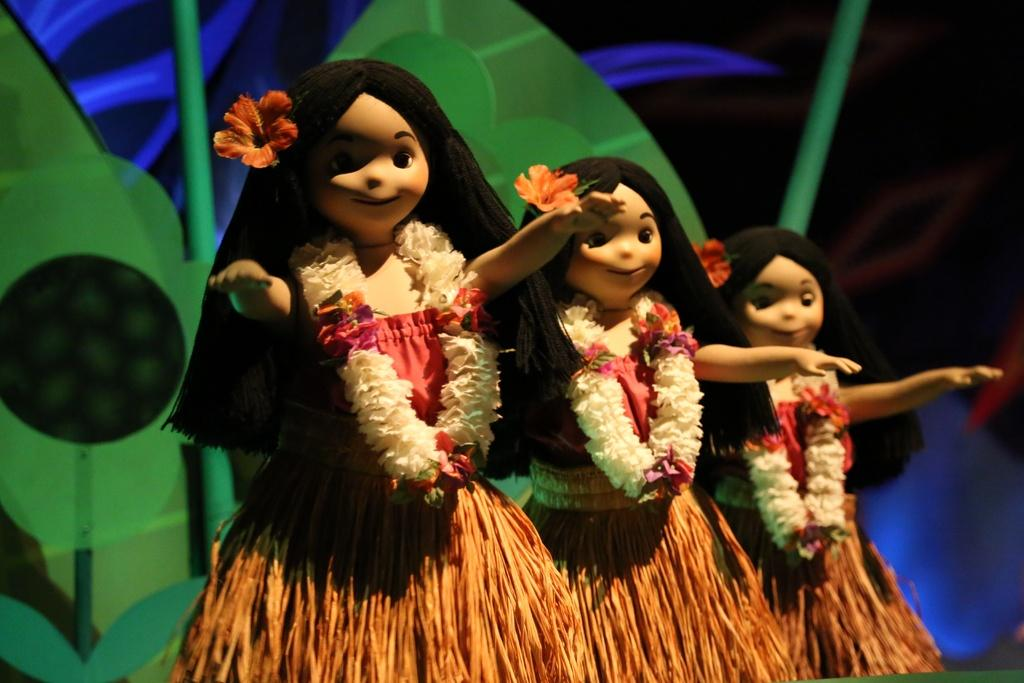What objects can be seen in the image? There are toys in the image. What type of vegetation is present in the background of the image? There are artificial plants in the background of the image. Can you describe any additional features in the image? There might be lights in the image. What is the plot of the story being told by the toys in the image? There is no story being told by the toys in the image, as they are inanimate objects and cannot communicate or convey a plot. 